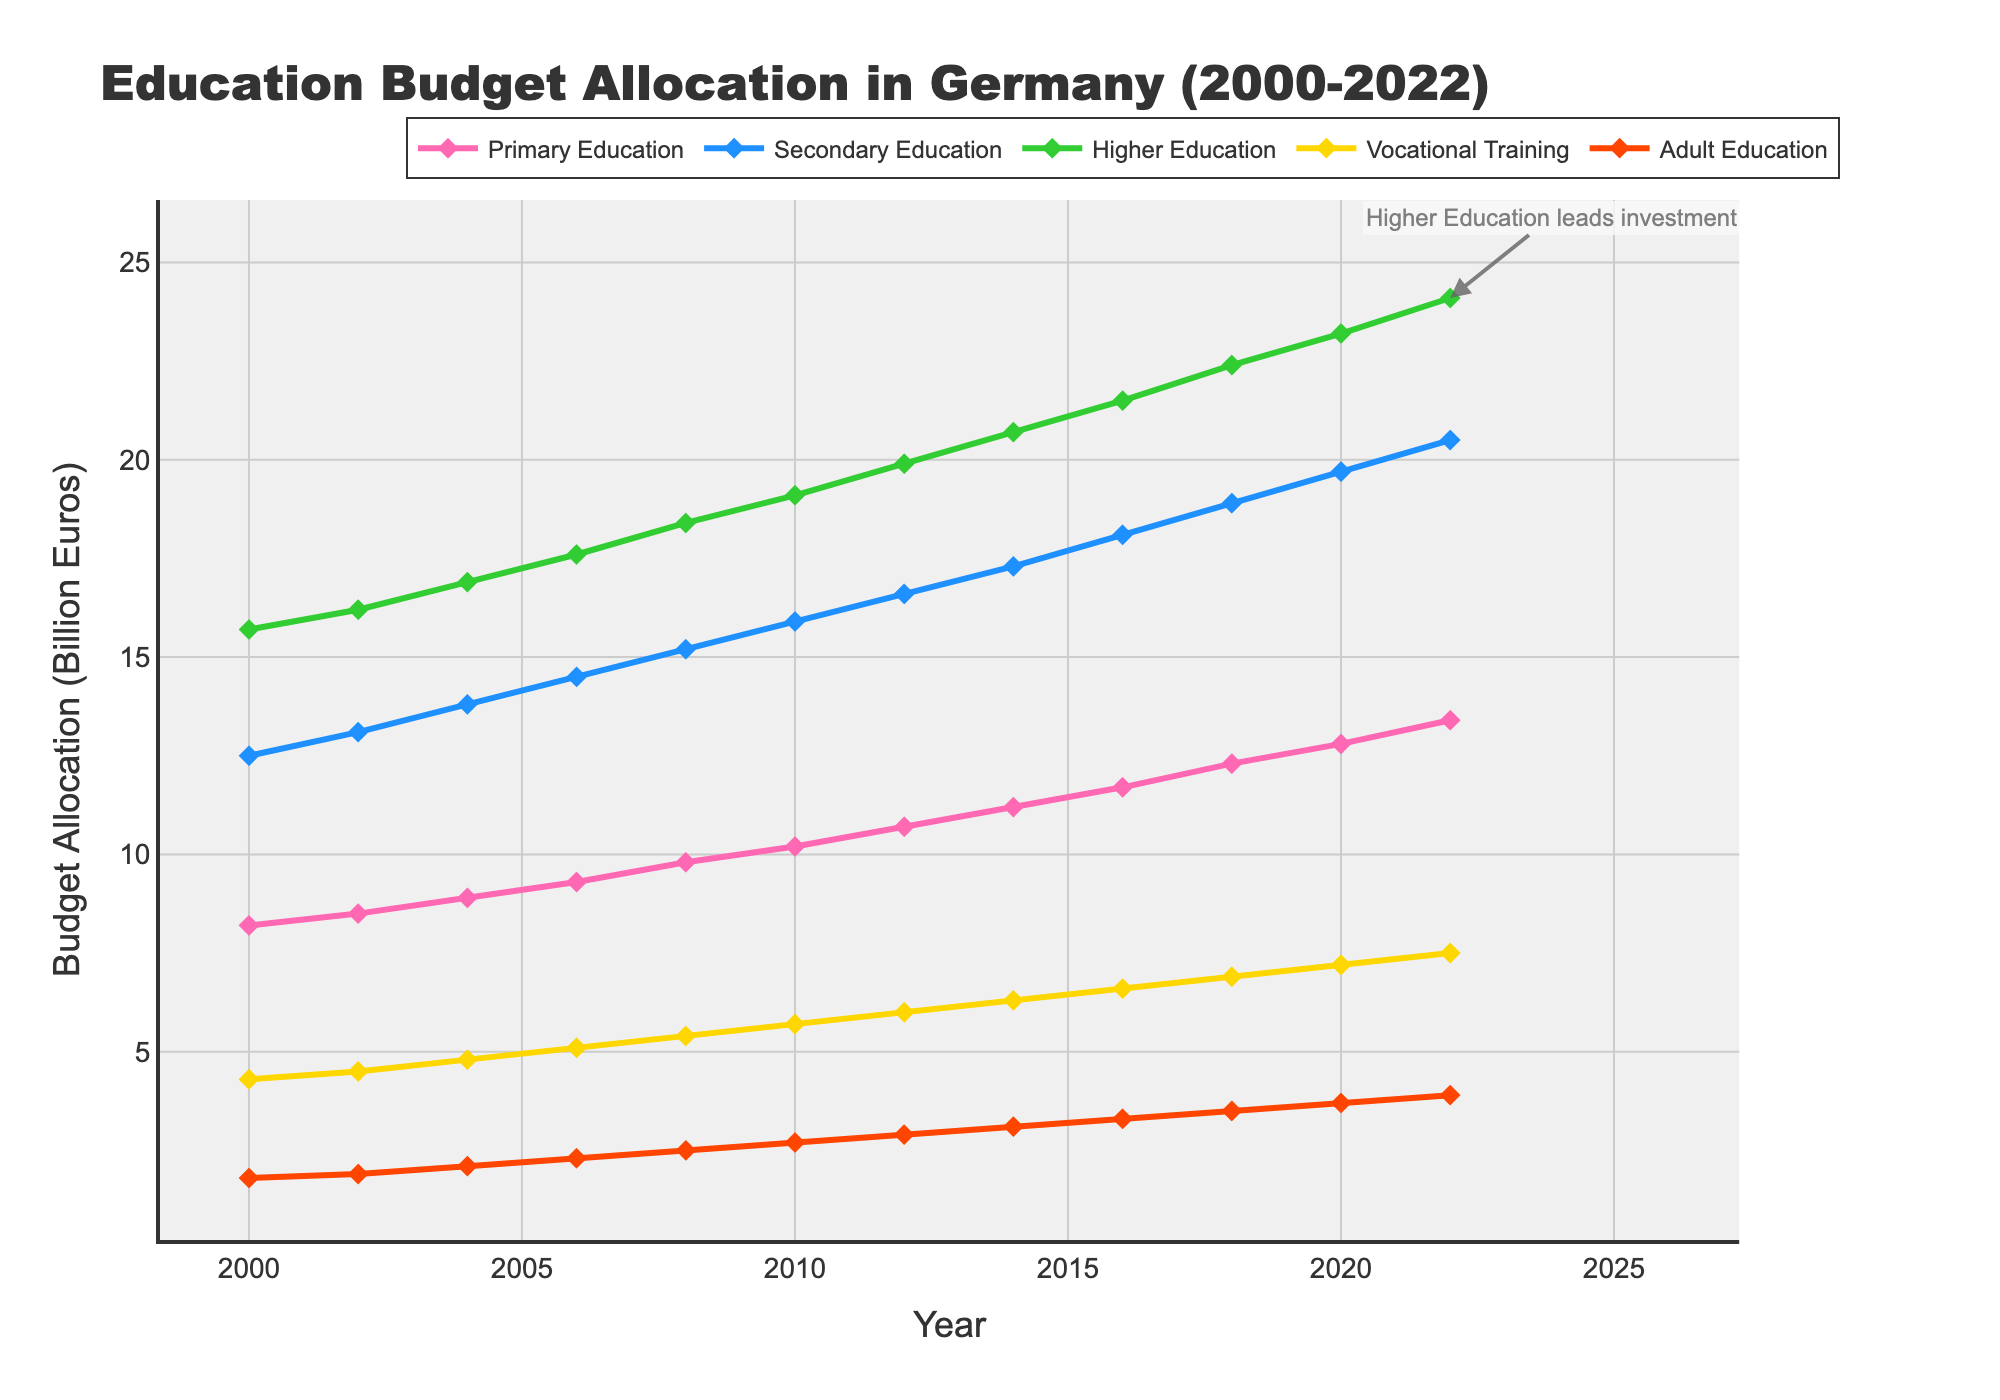Which educational sector received the highest budget allocation in 2022? The figure shows the budget allocation for different educational sectors over time. To find the highest allocation in 2022, look at the values for each sector in 2022. Higher Education has the highest value.
Answer: Higher Education What is the total budget allocation for Primary and Secondary Education in 2010? Check the values for Primary Education and Secondary Education in 2010. Add them together: 10.2 (Primary Education) + 15.9 (Secondary Education) = 26.1 billion euros.
Answer: 26.1 billion euros Which educational sector had the fastest growth between 2000 and 2022? Examine the slopes of the lines for each sector between 2000 and 2022. Higher Education shows the steepest increase.
Answer: Higher Education Which educational sector showed the smallest increase in budget allocation over the years? Compare the increases for each sector from 2000 to 2022 by looking at the difference in values. Adult Education shows the smallest increase from 1.8 to 3.9.
Answer: Adult Education How did the budget allocation for Vocational Training change between 2004 and 2012? Look at the budget allocation for Vocational Training in 2004 and 2012: 4.8 in 2004 and 6.0 in 2012. The change is calculated by the difference: 6.0 - 4.8 = 1.2.
Answer: Increased by 1.2 billion euros What was the approximate average annual increase in the budget for Higher Education from 2000 to 2022? Determine the increase over the period: 24.1 (2022) - 15.7 (2000) = 8.4 billion euros. Divide by the number of years: 8.4 / 22 ≈ 0.381.
Answer: Approximately 0.381 billion euros per year Which two sectors had almost parallel trends in budget allocation throughout the years? Look for two lines that appear parallel. Primary and Secondary Education lines are close to parallel throughout the years.
Answer: Primary and Secondary Education In what year did the budget allocation for Secondary Education first exceed 15 billion euros? Find the point where the line for Secondary Education crosses 15 billion euros. This occurs in 2008.
Answer: 2008 How much more was allocated to Higher Education than to Adult Education in 2022? Subtract the budget for Adult Education from the budget for Higher Education in 2022: 24.1 - 3.9 = 20.2 billion euros.
Answer: 20.2 billion euros 